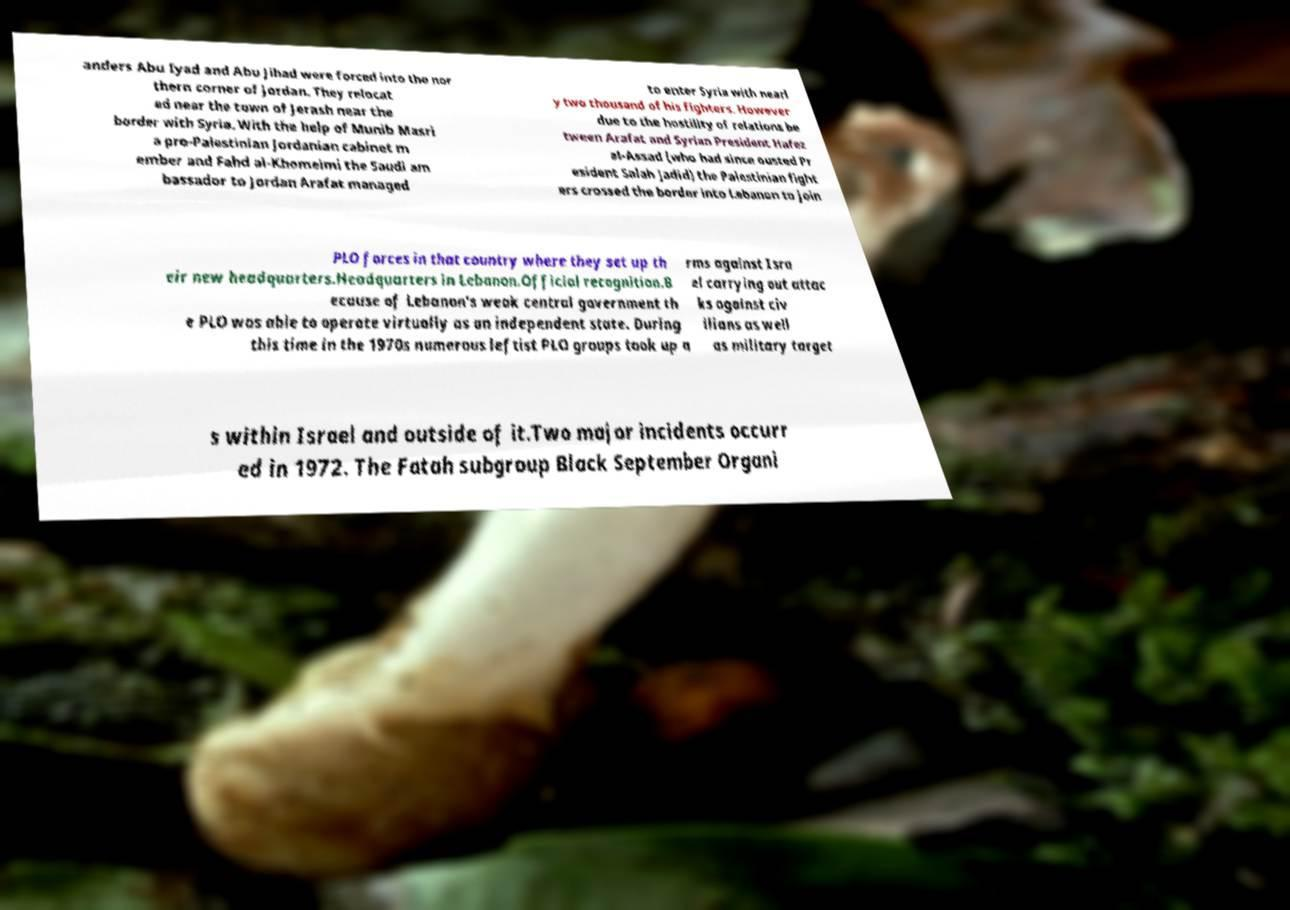I need the written content from this picture converted into text. Can you do that? anders Abu Iyad and Abu Jihad were forced into the nor thern corner of Jordan. They relocat ed near the town of Jerash near the border with Syria. With the help of Munib Masri a pro-Palestinian Jordanian cabinet m ember and Fahd al-Khomeimi the Saudi am bassador to Jordan Arafat managed to enter Syria with nearl y two thousand of his fighters. However due to the hostility of relations be tween Arafat and Syrian President Hafez al-Assad (who had since ousted Pr esident Salah Jadid) the Palestinian fight ers crossed the border into Lebanon to join PLO forces in that country where they set up th eir new headquarters.Headquarters in Lebanon.Official recognition.B ecause of Lebanon's weak central government th e PLO was able to operate virtually as an independent state. During this time in the 1970s numerous leftist PLO groups took up a rms against Isra el carrying out attac ks against civ ilians as well as military target s within Israel and outside of it.Two major incidents occurr ed in 1972. The Fatah subgroup Black September Organi 